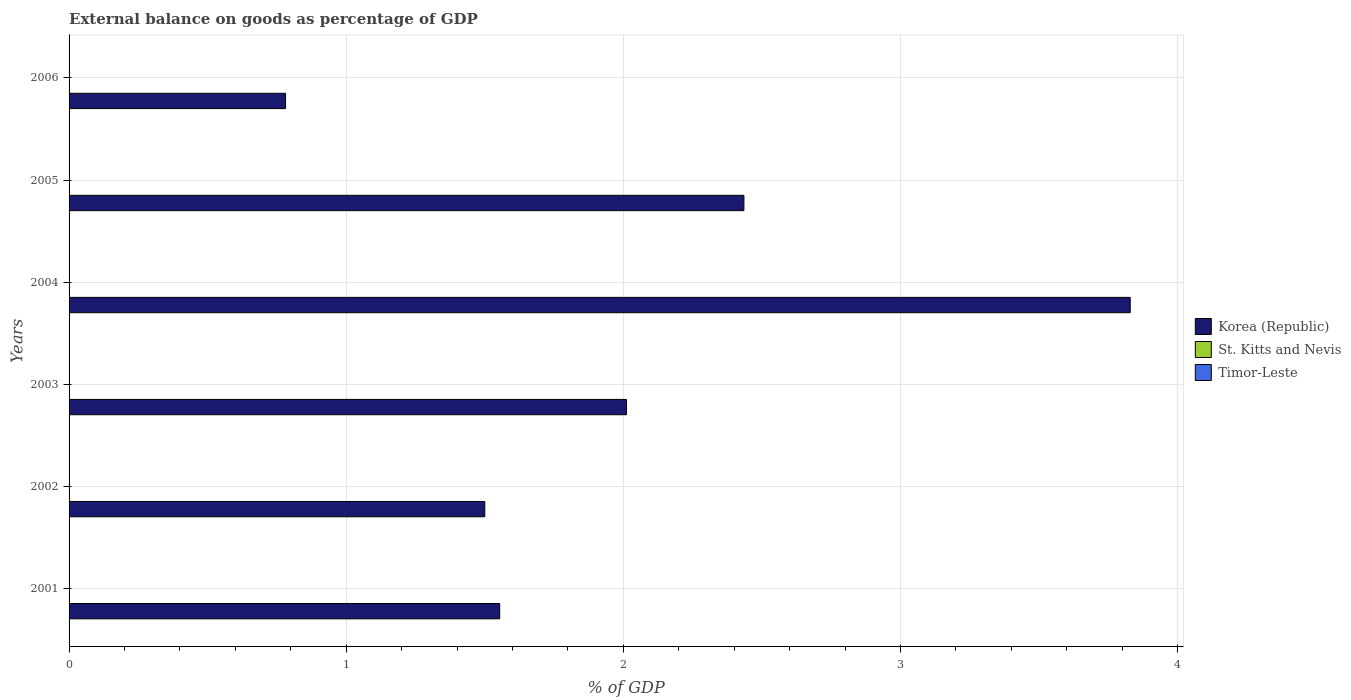Are the number of bars on each tick of the Y-axis equal?
Your response must be concise. Yes. How many bars are there on the 4th tick from the top?
Your answer should be compact. 1. What is the label of the 5th group of bars from the top?
Provide a short and direct response. 2002. What is the external balance on goods as percentage of GDP in St. Kitts and Nevis in 2002?
Make the answer very short. 0. Across all years, what is the maximum external balance on goods as percentage of GDP in Korea (Republic)?
Offer a very short reply. 3.83. In which year was the external balance on goods as percentage of GDP in Korea (Republic) maximum?
Offer a very short reply. 2004. What is the difference between the external balance on goods as percentage of GDP in Korea (Republic) in 2001 and that in 2005?
Your response must be concise. -0.88. What is the difference between the external balance on goods as percentage of GDP in Timor-Leste in 2006 and the external balance on goods as percentage of GDP in St. Kitts and Nevis in 2002?
Your answer should be compact. 0. What is the average external balance on goods as percentage of GDP in Korea (Republic) per year?
Your answer should be very brief. 2.02. What is the ratio of the external balance on goods as percentage of GDP in Korea (Republic) in 2003 to that in 2006?
Your answer should be compact. 2.57. Is the external balance on goods as percentage of GDP in Korea (Republic) in 2001 less than that in 2002?
Make the answer very short. No. Is it the case that in every year, the sum of the external balance on goods as percentage of GDP in St. Kitts and Nevis and external balance on goods as percentage of GDP in Timor-Leste is greater than the external balance on goods as percentage of GDP in Korea (Republic)?
Make the answer very short. No. How many bars are there?
Your answer should be very brief. 6. Are the values on the major ticks of X-axis written in scientific E-notation?
Provide a succinct answer. No. Does the graph contain grids?
Your answer should be very brief. Yes. What is the title of the graph?
Ensure brevity in your answer.  External balance on goods as percentage of GDP. What is the label or title of the X-axis?
Provide a succinct answer. % of GDP. What is the label or title of the Y-axis?
Offer a very short reply. Years. What is the % of GDP of Korea (Republic) in 2001?
Ensure brevity in your answer.  1.55. What is the % of GDP of Korea (Republic) in 2002?
Make the answer very short. 1.5. What is the % of GDP of Korea (Republic) in 2003?
Your answer should be very brief. 2.01. What is the % of GDP in Timor-Leste in 2003?
Give a very brief answer. 0. What is the % of GDP of Korea (Republic) in 2004?
Ensure brevity in your answer.  3.83. What is the % of GDP of Timor-Leste in 2004?
Keep it short and to the point. 0. What is the % of GDP in Korea (Republic) in 2005?
Ensure brevity in your answer.  2.44. What is the % of GDP in Timor-Leste in 2005?
Your response must be concise. 0. What is the % of GDP of Korea (Republic) in 2006?
Provide a succinct answer. 0.78. What is the % of GDP of Timor-Leste in 2006?
Offer a very short reply. 0. Across all years, what is the maximum % of GDP in Korea (Republic)?
Offer a very short reply. 3.83. Across all years, what is the minimum % of GDP of Korea (Republic)?
Keep it short and to the point. 0.78. What is the total % of GDP of Korea (Republic) in the graph?
Provide a short and direct response. 12.11. What is the total % of GDP of Timor-Leste in the graph?
Provide a short and direct response. 0. What is the difference between the % of GDP in Korea (Republic) in 2001 and that in 2002?
Give a very brief answer. 0.05. What is the difference between the % of GDP of Korea (Republic) in 2001 and that in 2003?
Offer a terse response. -0.46. What is the difference between the % of GDP in Korea (Republic) in 2001 and that in 2004?
Your response must be concise. -2.28. What is the difference between the % of GDP in Korea (Republic) in 2001 and that in 2005?
Your response must be concise. -0.88. What is the difference between the % of GDP of Korea (Republic) in 2001 and that in 2006?
Offer a very short reply. 0.77. What is the difference between the % of GDP in Korea (Republic) in 2002 and that in 2003?
Keep it short and to the point. -0.51. What is the difference between the % of GDP in Korea (Republic) in 2002 and that in 2004?
Offer a terse response. -2.33. What is the difference between the % of GDP in Korea (Republic) in 2002 and that in 2005?
Your response must be concise. -0.94. What is the difference between the % of GDP in Korea (Republic) in 2002 and that in 2006?
Your response must be concise. 0.72. What is the difference between the % of GDP in Korea (Republic) in 2003 and that in 2004?
Offer a terse response. -1.82. What is the difference between the % of GDP of Korea (Republic) in 2003 and that in 2005?
Your answer should be compact. -0.42. What is the difference between the % of GDP of Korea (Republic) in 2003 and that in 2006?
Keep it short and to the point. 1.23. What is the difference between the % of GDP in Korea (Republic) in 2004 and that in 2005?
Ensure brevity in your answer.  1.39. What is the difference between the % of GDP of Korea (Republic) in 2004 and that in 2006?
Make the answer very short. 3.05. What is the difference between the % of GDP of Korea (Republic) in 2005 and that in 2006?
Offer a terse response. 1.65. What is the average % of GDP of Korea (Republic) per year?
Your response must be concise. 2.02. What is the average % of GDP in Timor-Leste per year?
Your answer should be compact. 0. What is the ratio of the % of GDP of Korea (Republic) in 2001 to that in 2002?
Make the answer very short. 1.04. What is the ratio of the % of GDP in Korea (Republic) in 2001 to that in 2003?
Keep it short and to the point. 0.77. What is the ratio of the % of GDP in Korea (Republic) in 2001 to that in 2004?
Provide a short and direct response. 0.41. What is the ratio of the % of GDP of Korea (Republic) in 2001 to that in 2005?
Make the answer very short. 0.64. What is the ratio of the % of GDP of Korea (Republic) in 2001 to that in 2006?
Give a very brief answer. 1.99. What is the ratio of the % of GDP in Korea (Republic) in 2002 to that in 2003?
Provide a succinct answer. 0.75. What is the ratio of the % of GDP of Korea (Republic) in 2002 to that in 2004?
Offer a terse response. 0.39. What is the ratio of the % of GDP of Korea (Republic) in 2002 to that in 2005?
Make the answer very short. 0.62. What is the ratio of the % of GDP of Korea (Republic) in 2002 to that in 2006?
Your response must be concise. 1.92. What is the ratio of the % of GDP in Korea (Republic) in 2003 to that in 2004?
Give a very brief answer. 0.53. What is the ratio of the % of GDP of Korea (Republic) in 2003 to that in 2005?
Give a very brief answer. 0.83. What is the ratio of the % of GDP in Korea (Republic) in 2003 to that in 2006?
Make the answer very short. 2.57. What is the ratio of the % of GDP of Korea (Republic) in 2004 to that in 2005?
Make the answer very short. 1.57. What is the ratio of the % of GDP in Korea (Republic) in 2004 to that in 2006?
Offer a terse response. 4.9. What is the ratio of the % of GDP of Korea (Republic) in 2005 to that in 2006?
Provide a short and direct response. 3.12. What is the difference between the highest and the second highest % of GDP in Korea (Republic)?
Your response must be concise. 1.39. What is the difference between the highest and the lowest % of GDP in Korea (Republic)?
Your answer should be very brief. 3.05. 